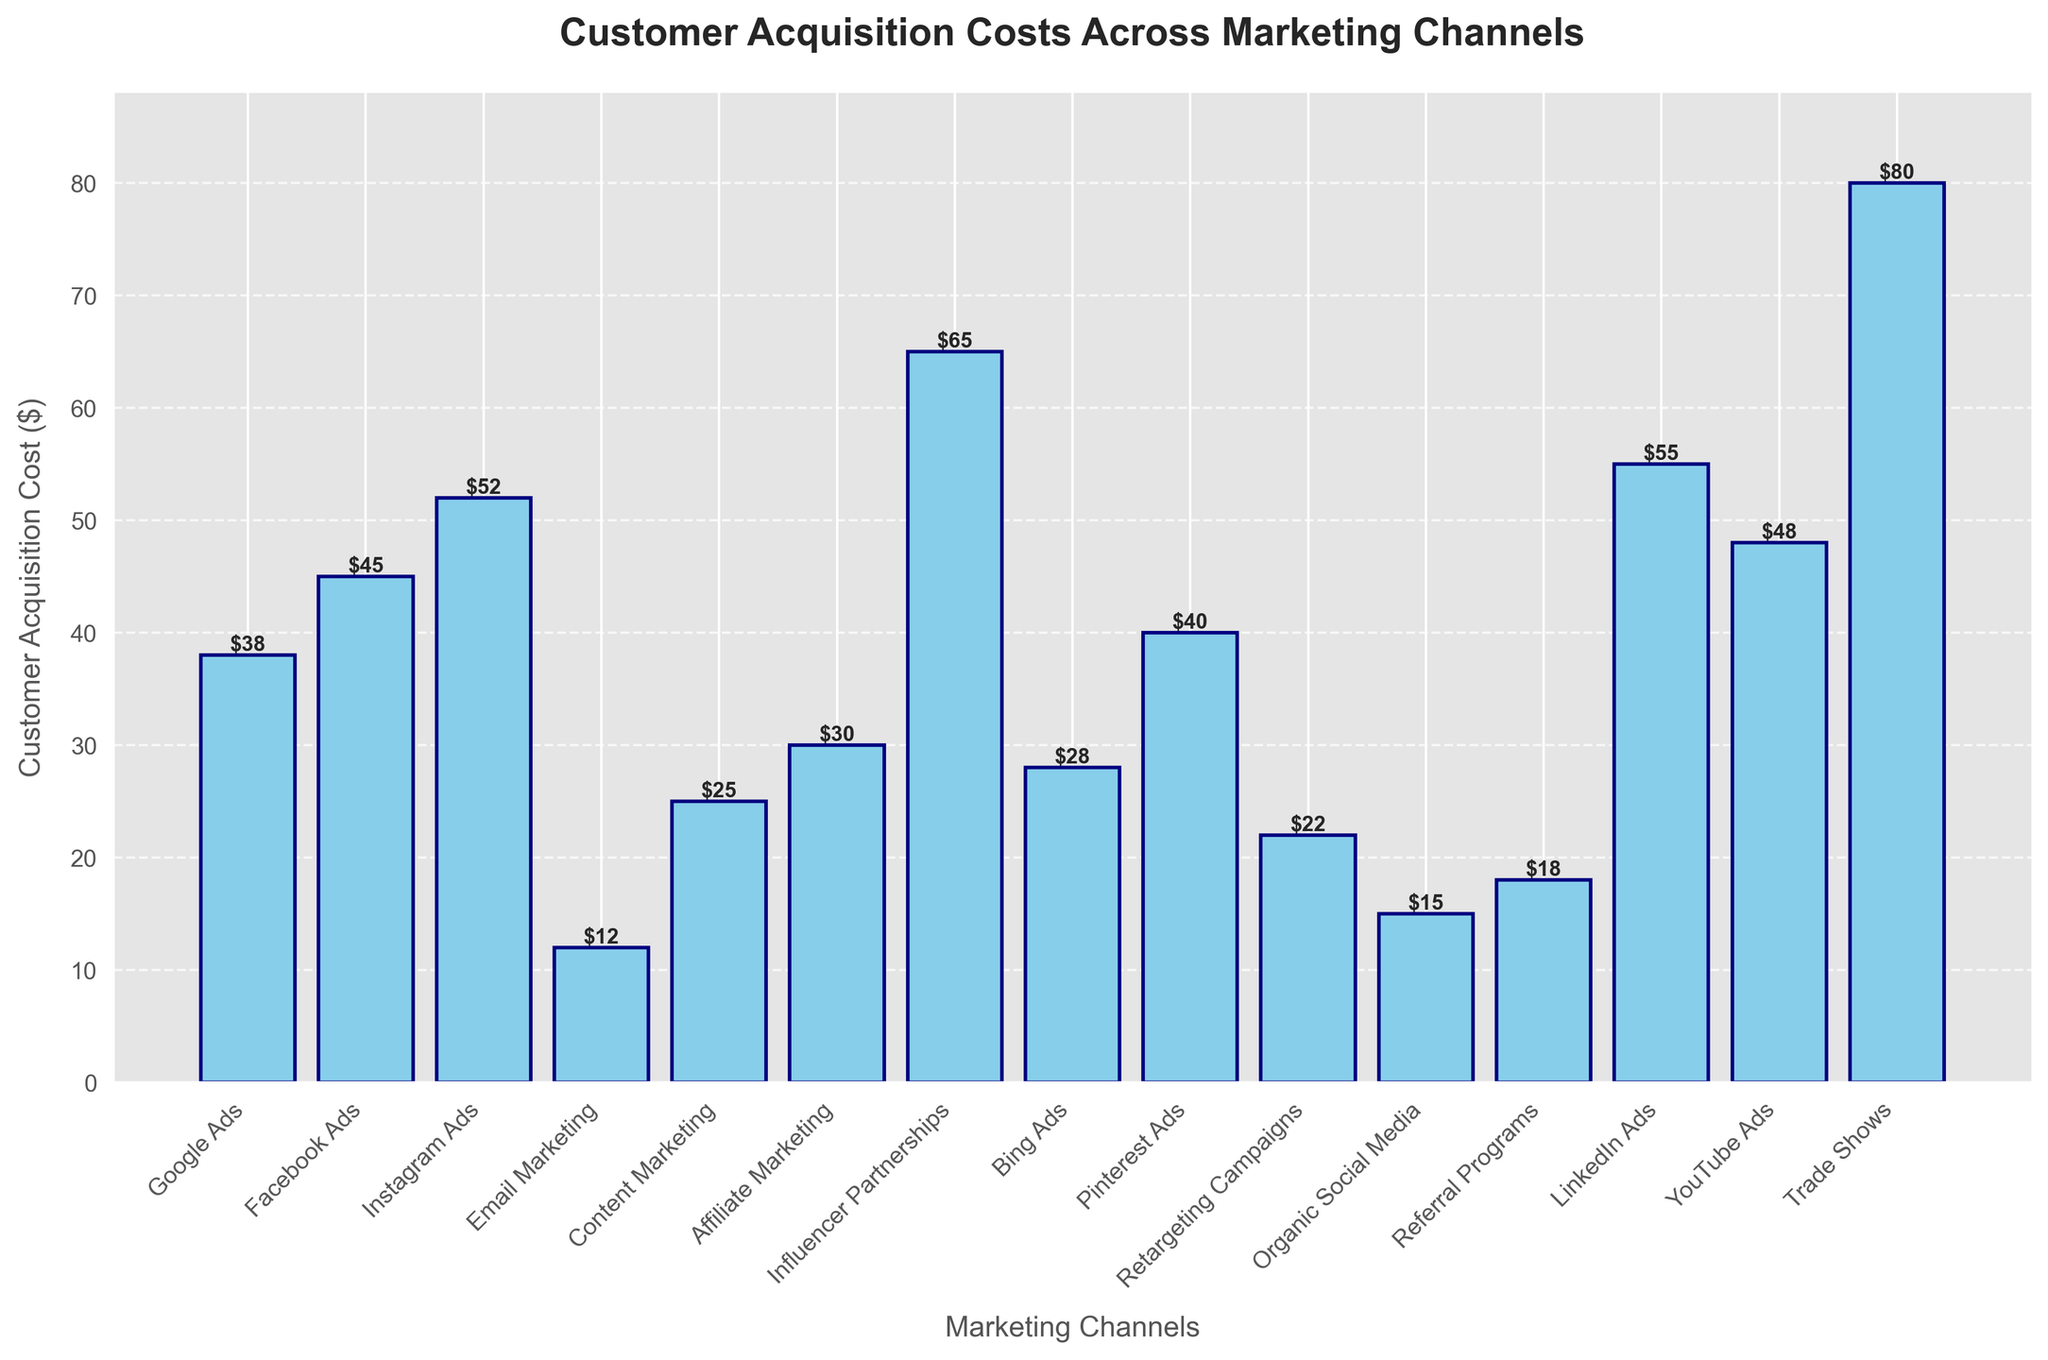What is the highest customer acquisition cost among the channels? The tallest bar represents the highest customer acquisition cost. The title and labels indicate it corresponds to Trade Shows with a value of $80.
Answer: $80 Which marketing channel has the lowest customer acquisition cost? The shortest bar represents the lowest customer acquisition cost, which corresponds to Email Marketing with a value of $12.
Answer: Email Marketing How much higher is the cost of Influencer Partnerships compared to Organic Social Media? Find the heights of the bars for Influencer Partnerships ($65) and Organic Social Media ($15), then subtract the two values: $65 - $15 = $50
Answer: $50 Which marketing channel has a customer acquisition cost closest to $30? Look for the bar heights near $30. Affiliate Marketing has a cost of $30, which is exactly $30.
Answer: Affiliate Marketing Rank the top three marketing channels by their customer acquisition cost. Identify the three tallest bars. They correspond to Trade Shows ($80), Influencer Partnerships ($65), and LinkedIn Ads ($55).
Answer: Trade Shows, Influencer Partnerships, LinkedIn Ads What is the total customer acquisition cost for Google Ads, Facebook Ads, and Instagram Ads combined? Add the costs of Google Ads ($38), Facebook Ads ($45), and Instagram Ads ($52): $38 + $45 + $52 = $135
Answer: $135 Is the customer acquisition cost of YouTube Ads greater than that of Pinterest Ads? Compare the bar heights for YouTube Ads ($48) and Pinterest Ads ($40). Yes, $48 is greater than $40.
Answer: Yes What is the average customer acquisition cost across all marketing channels? Sum up all the costs and divide by the number of channels. Total cost = $38 + $45 + $52 + $12 + $25 + $30 + $65 + $28 + $40 + $22 + $15 + $18 + $55 + $48 + $80 = $573. There are 15 channels, so average = $573 / 15 = $38.2
Answer: $38.2 How many channels have a customer acquisition cost higher than $50? Identify bars higher than $50: Instagram Ads ($52), Influencer Partnerships ($65), LinkedIn Ads ($55), and Trade Shows ($80). There are 4 such channels.
Answer: 4 Which costs more: Email Marketing and Retargeting Campaigns combined or Facebook Ads alone? Add costs of Email Marketing ($12) and Retargeting Campaigns ($22): $12 + $22 = $34. Facebook Ads cost $45. $34 is less than $45, so Facebook Ads alone cost more.
Answer: Facebook Ads 